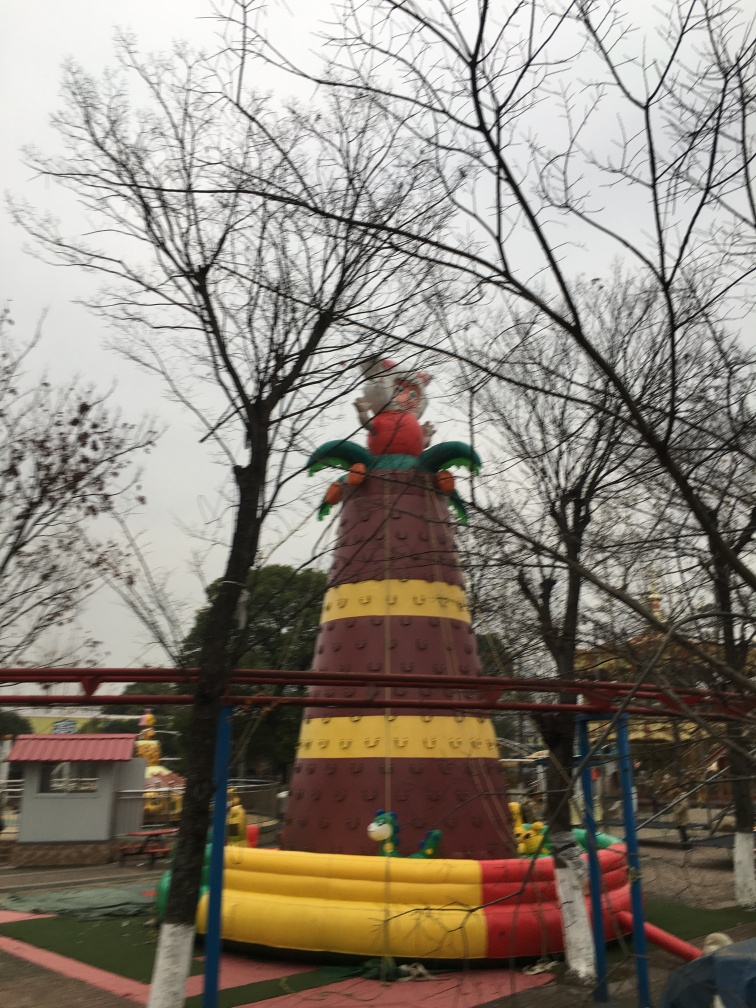What is the time of day or weather condition in this image? The sky is overcast, suggesting it might be a cloudy day, which could indicate early morning, late afternoon, or simply cloudy weather at any time during daylight hours. 